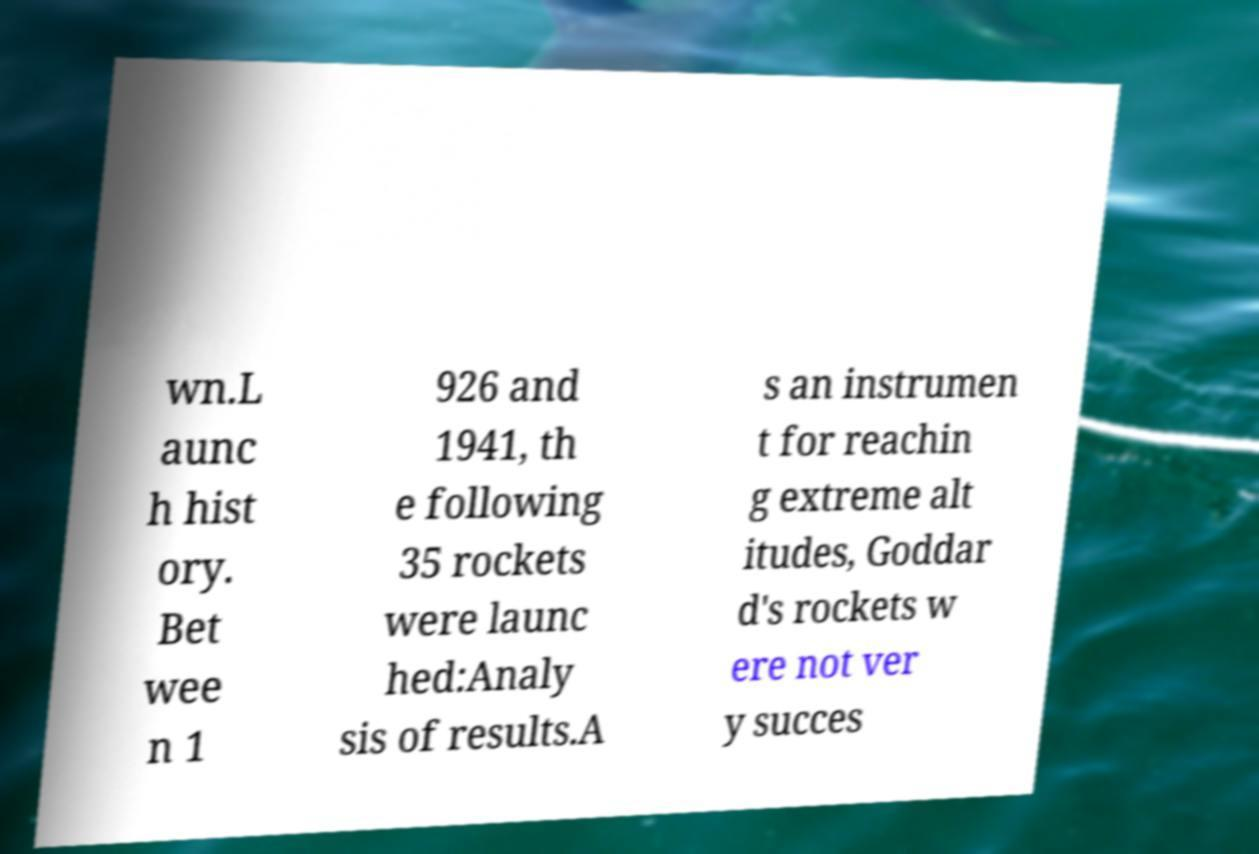Can you accurately transcribe the text from the provided image for me? wn.L aunc h hist ory. Bet wee n 1 926 and 1941, th e following 35 rockets were launc hed:Analy sis of results.A s an instrumen t for reachin g extreme alt itudes, Goddar d's rockets w ere not ver y succes 